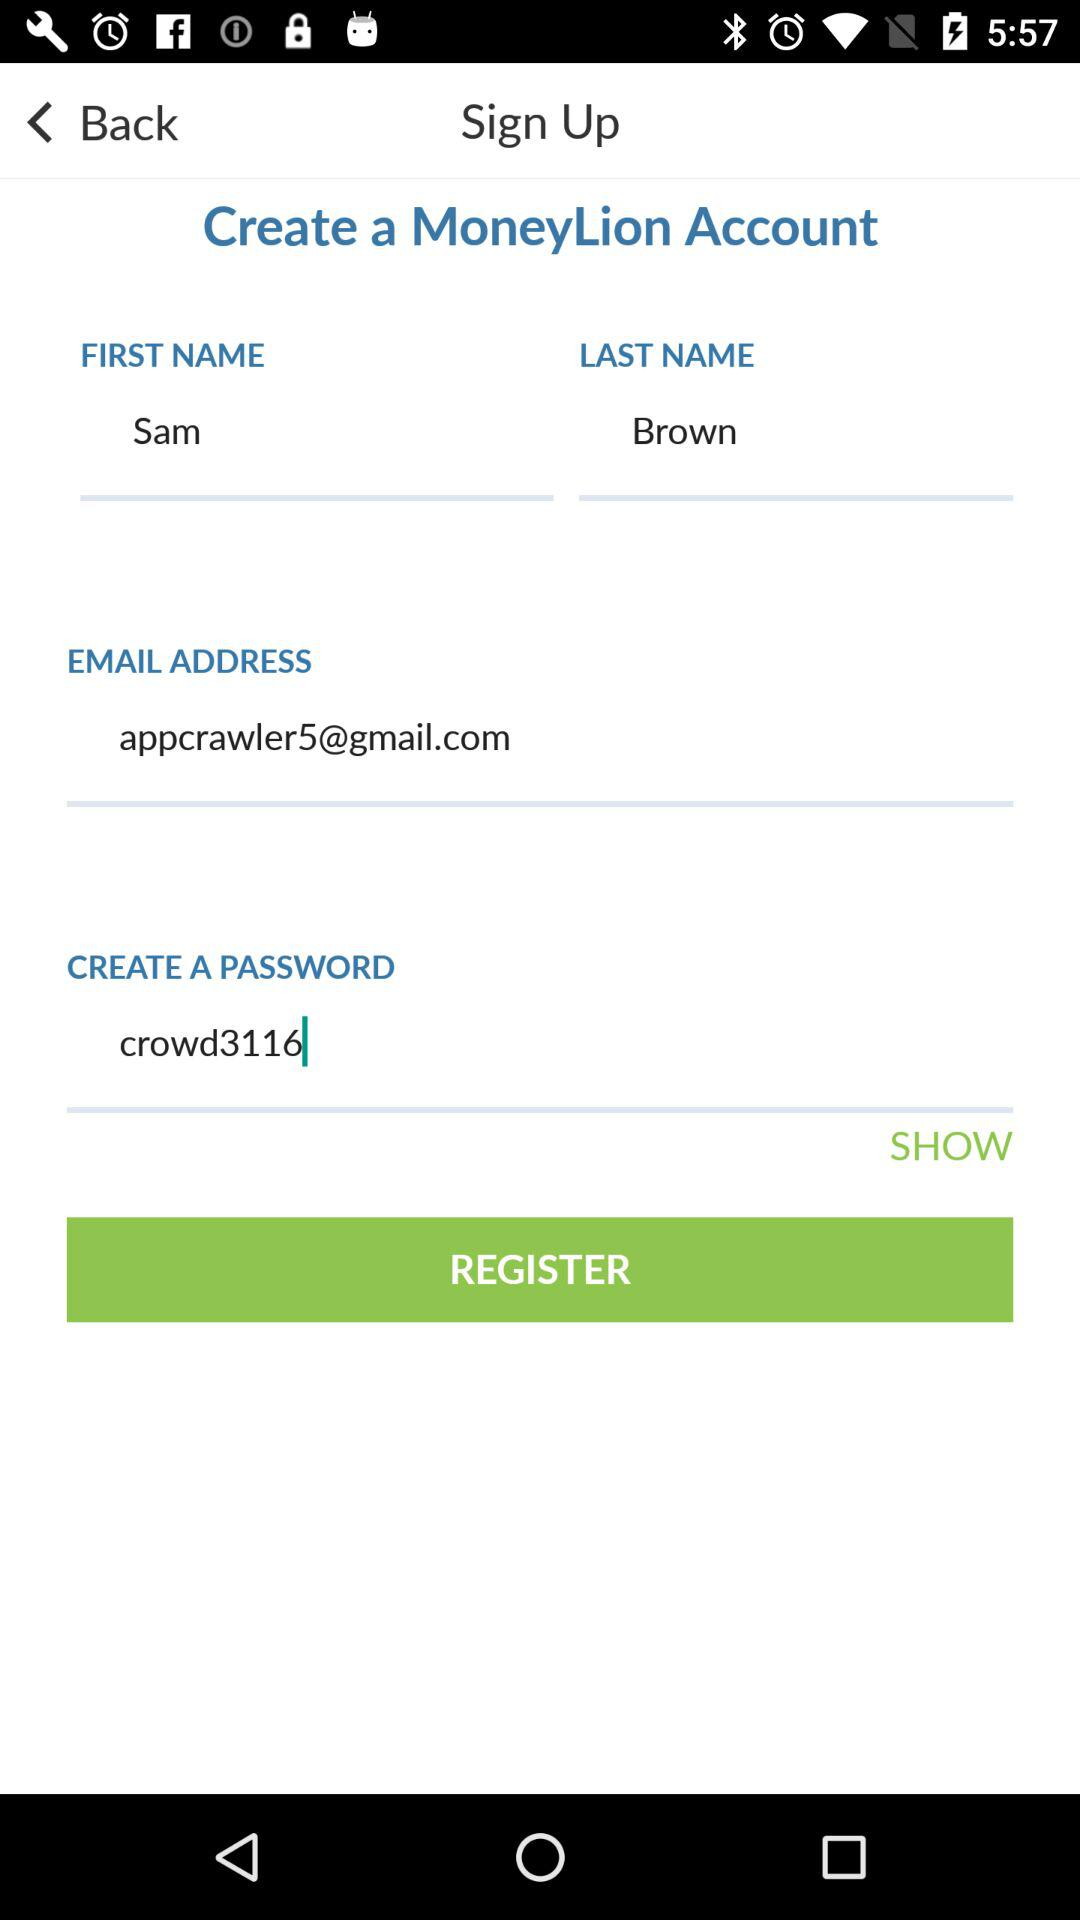What is the password of the user? The password of the user is "crowd3116". 